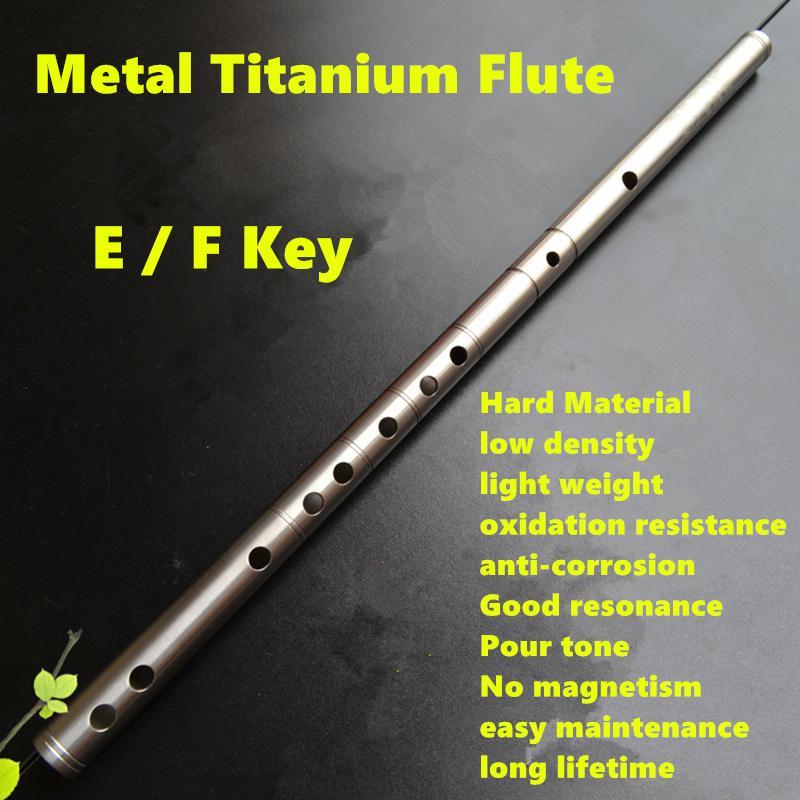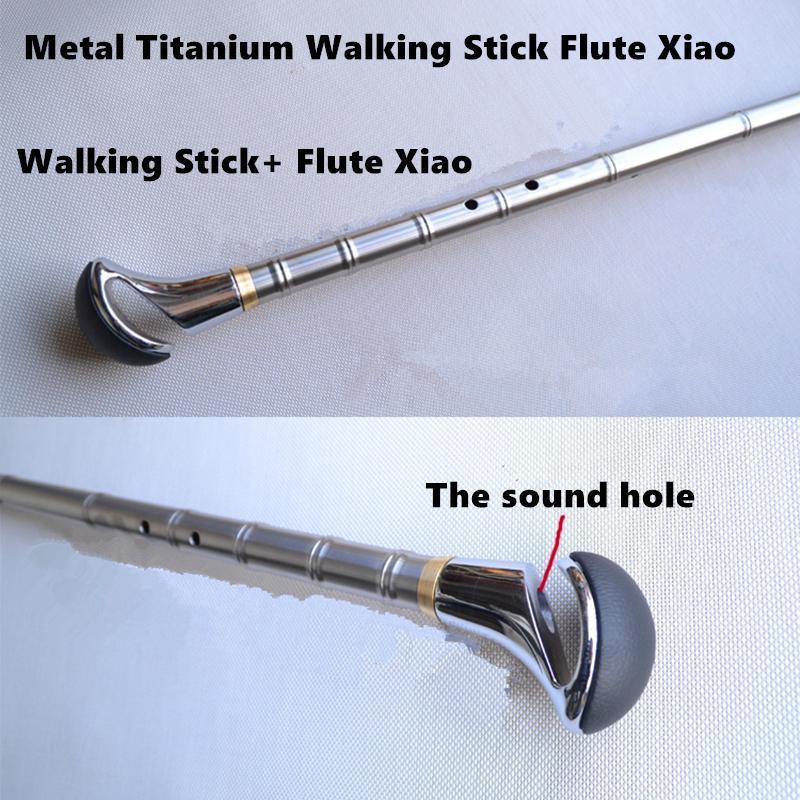The first image is the image on the left, the second image is the image on the right. Assess this claim about the two images: "Three instruments lie in a row in one of the images.". Correct or not? Answer yes or no. No. The first image is the image on the left, the second image is the image on the right. Considering the images on both sides, is "There are exactly five objects." valid? Answer yes or no. No. 